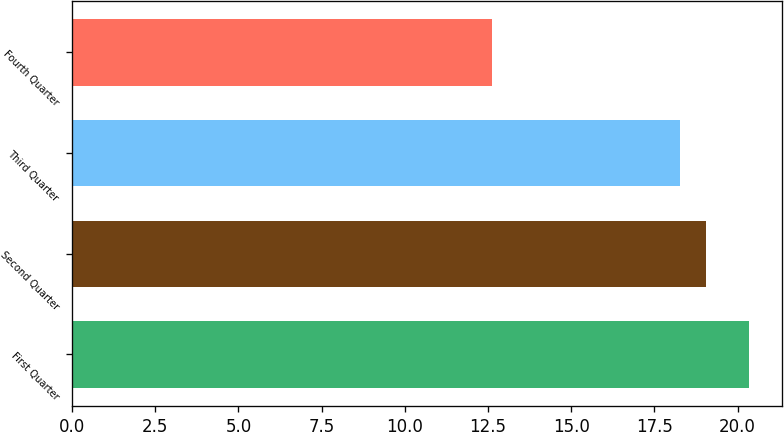Convert chart. <chart><loc_0><loc_0><loc_500><loc_500><bar_chart><fcel>First Quarter<fcel>Second Quarter<fcel>Third Quarter<fcel>Fourth Quarter<nl><fcel>20.33<fcel>19.04<fcel>18.27<fcel>12.61<nl></chart> 